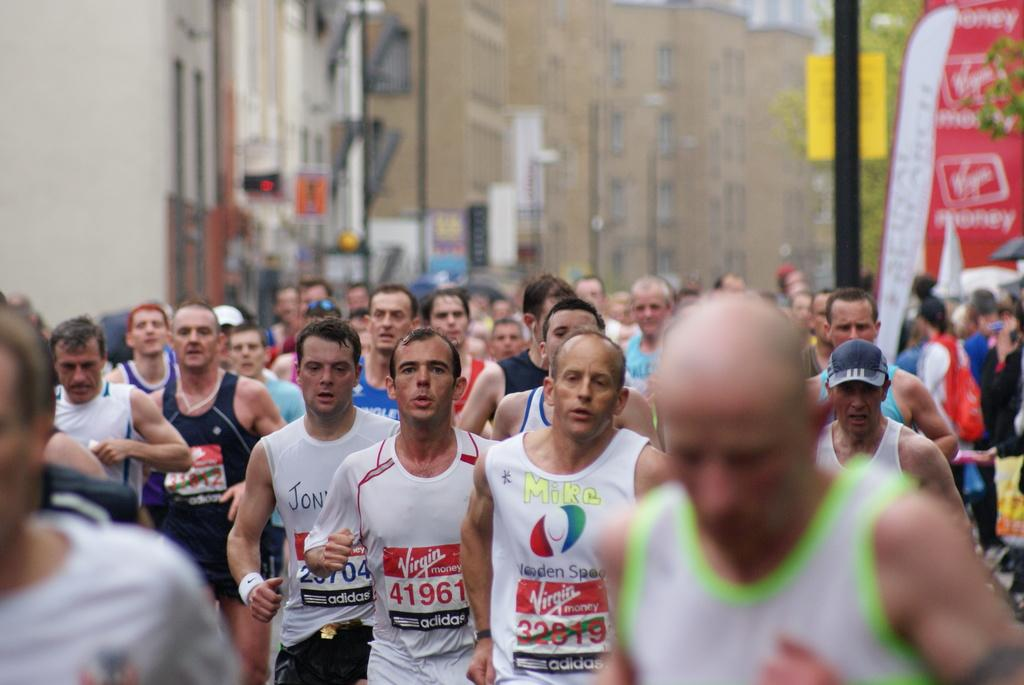How many people are in the image? There is a group of people in the image. What are the people doing in the image? The people are running. What can be seen in the background of the image? There are buildings, poles, boards, and trees in the background of the image. How many tents are set up in the image? There is no tent present in the image. What is the limit of the people running in the image? The image does not specify a limit for the people running; they are simply running. 